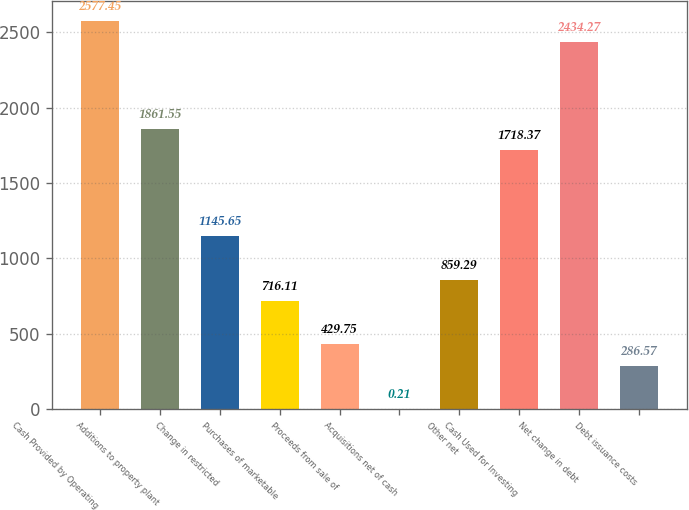<chart> <loc_0><loc_0><loc_500><loc_500><bar_chart><fcel>Cash Provided by Operating<fcel>Additions to property plant<fcel>Change in restricted<fcel>Purchases of marketable<fcel>Proceeds from sale of<fcel>Acquisitions net of cash<fcel>Other net<fcel>Cash Used for Investing<fcel>Net change in debt<fcel>Debt issuance costs<nl><fcel>2577.45<fcel>1861.55<fcel>1145.65<fcel>716.11<fcel>429.75<fcel>0.21<fcel>859.29<fcel>1718.37<fcel>2434.27<fcel>286.57<nl></chart> 